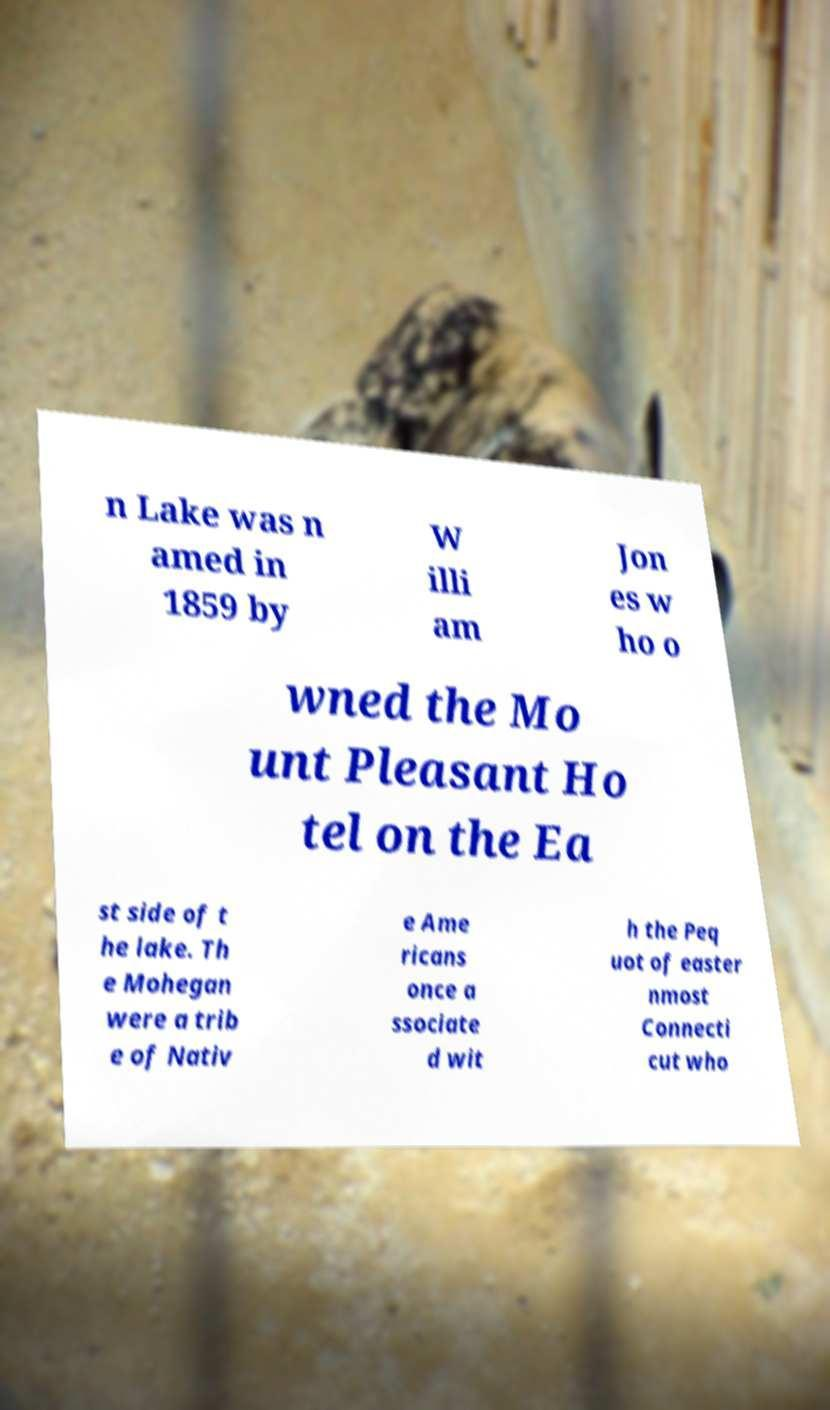For documentation purposes, I need the text within this image transcribed. Could you provide that? n Lake was n amed in 1859 by W illi am Jon es w ho o wned the Mo unt Pleasant Ho tel on the Ea st side of t he lake. Th e Mohegan were a trib e of Nativ e Ame ricans once a ssociate d wit h the Peq uot of easter nmost Connecti cut who 